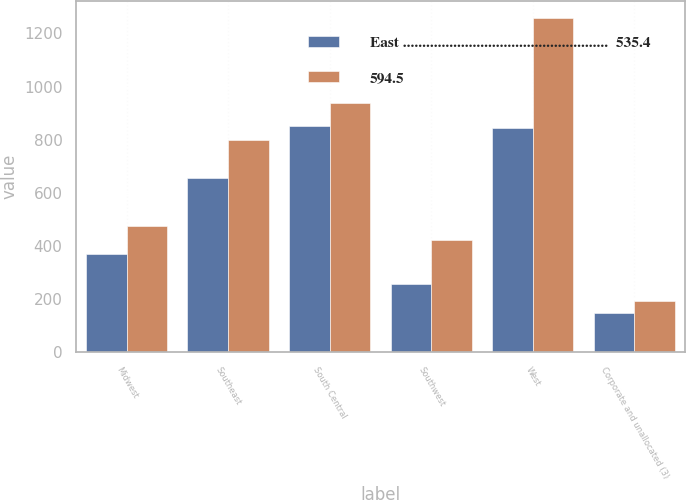Convert chart. <chart><loc_0><loc_0><loc_500><loc_500><stacked_bar_chart><ecel><fcel>Midwest<fcel>Southeast<fcel>South Central<fcel>Southwest<fcel>West<fcel>Corporate and unallocated (3)<nl><fcel>East .....................................................  535.4<fcel>371.1<fcel>656.6<fcel>852.8<fcel>255.7<fcel>842.5<fcel>148.9<nl><fcel>594.5<fcel>473.8<fcel>799.6<fcel>939.7<fcel>423.6<fcel>1258.4<fcel>193.6<nl></chart> 